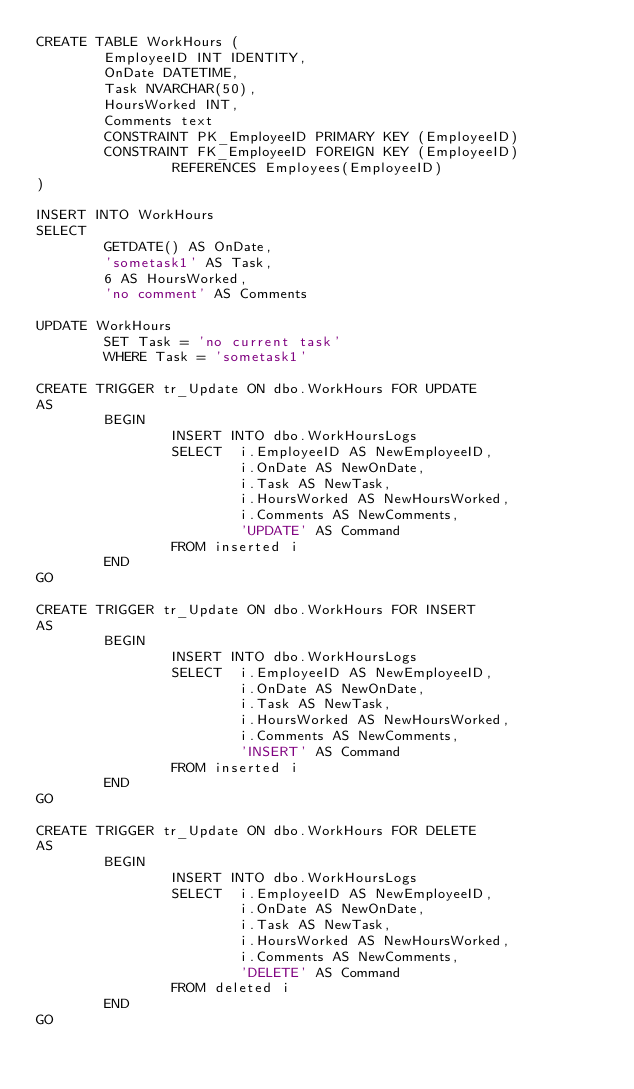Convert code to text. <code><loc_0><loc_0><loc_500><loc_500><_SQL_>CREATE TABLE WorkHours (
        EmployeeID INT IDENTITY,
        OnDate DATETIME,
        Task NVARCHAR(50),
        HoursWorked INT,
        Comments text
        CONSTRAINT PK_EmployeeID PRIMARY KEY (EmployeeID)
        CONSTRAINT FK_EmployeeID FOREIGN KEY (EmployeeID)
                REFERENCES Employees(EmployeeID)
)
 
INSERT INTO WorkHours
SELECT
        GETDATE() AS OnDate,
        'sometask1' AS Task,
        6 AS HoursWorked,
        'no comment' AS Comments
 
UPDATE WorkHours
        SET Task = 'no current task'
        WHERE Task = 'sometask1'
 
CREATE TRIGGER tr_Update ON dbo.WorkHours FOR UPDATE
AS
        BEGIN
                INSERT INTO dbo.WorkHoursLogs
                SELECT  i.EmployeeID AS NewEmployeeID,
                        i.OnDate AS NewOnDate,
                        i.Task AS NewTask,
                        i.HoursWorked AS NewHoursWorked,
                        i.Comments AS NewComments,
                        'UPDATE' AS Command
                FROM inserted i
        END
GO
 
CREATE TRIGGER tr_Update ON dbo.WorkHours FOR INSERT
AS
        BEGIN
                INSERT INTO dbo.WorkHoursLogs
                SELECT  i.EmployeeID AS NewEmployeeID,
                        i.OnDate AS NewOnDate,
                        i.Task AS NewTask,
                        i.HoursWorked AS NewHoursWorked,
                        i.Comments AS NewComments,
                        'INSERT' AS Command
                FROM inserted i
        END
GO
 
CREATE TRIGGER tr_Update ON dbo.WorkHours FOR DELETE
AS
        BEGIN
                INSERT INTO dbo.WorkHoursLogs
                SELECT  i.EmployeeID AS NewEmployeeID,
                        i.OnDate AS NewOnDate,
                        i.Task AS NewTask,
                        i.HoursWorked AS NewHoursWorked,
                        i.Comments AS NewComments,
                        'DELETE' AS Command
                FROM deleted i
        END
GO</code> 